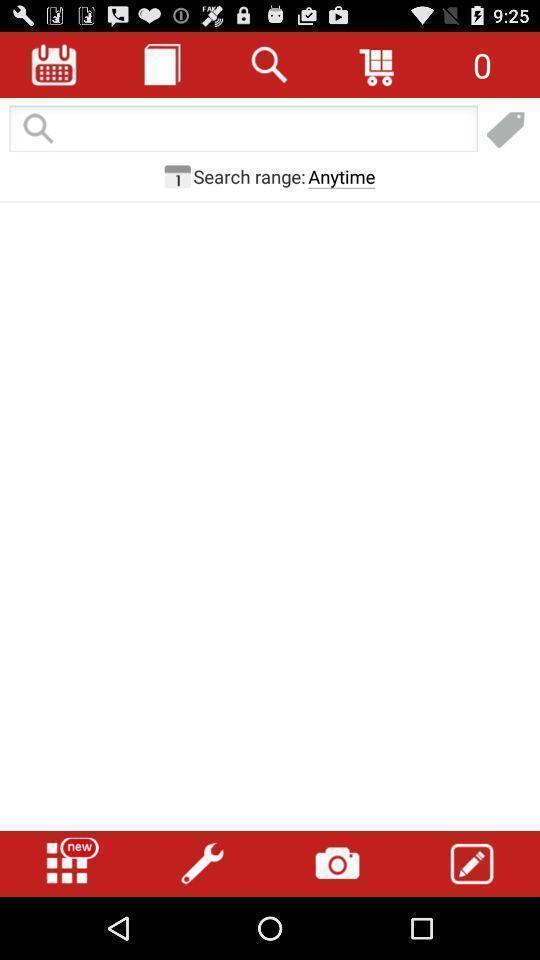What is the overall content of this screenshot? Search page with various options on app. 